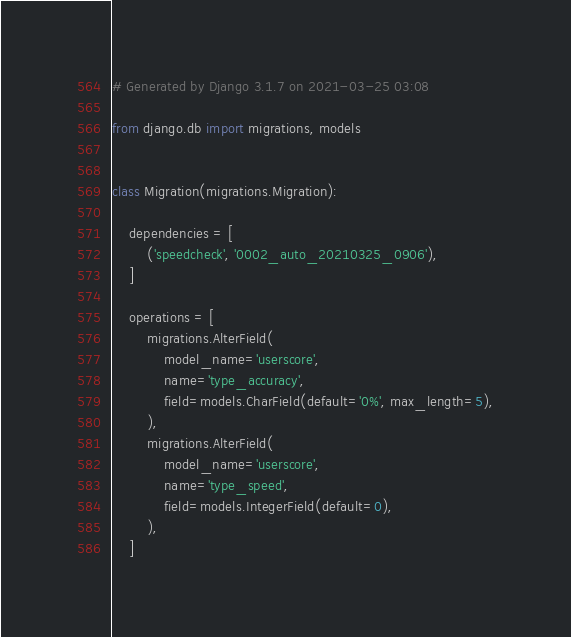Convert code to text. <code><loc_0><loc_0><loc_500><loc_500><_Python_># Generated by Django 3.1.7 on 2021-03-25 03:08

from django.db import migrations, models


class Migration(migrations.Migration):

    dependencies = [
        ('speedcheck', '0002_auto_20210325_0906'),
    ]

    operations = [
        migrations.AlterField(
            model_name='userscore',
            name='type_accuracy',
            field=models.CharField(default='0%', max_length=5),
        ),
        migrations.AlterField(
            model_name='userscore',
            name='type_speed',
            field=models.IntegerField(default=0),
        ),
    ]
</code> 